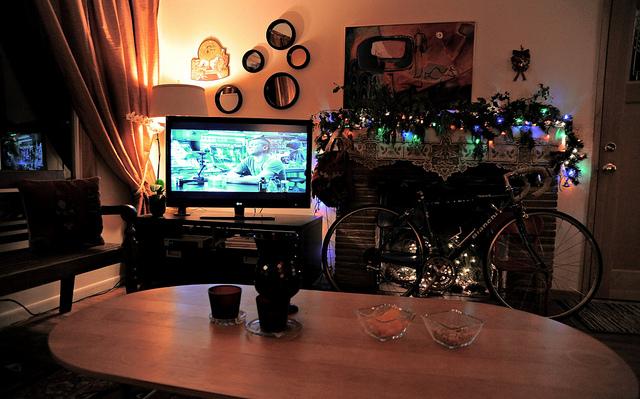Is the TV turned on or off?
Short answer required. On. How many circle pictures are on the wall?
Answer briefly. 5. Is the apartment messy?
Short answer required. No. 